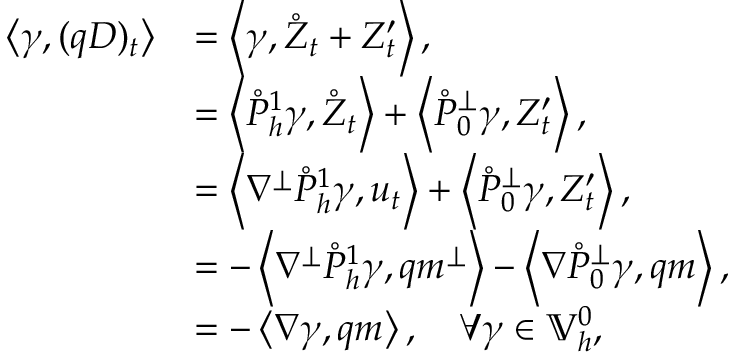<formula> <loc_0><loc_0><loc_500><loc_500>\begin{array} { r l } { \left \langle \gamma , ( q D ) _ { t } \right \rangle } & { = \left \langle \gamma , \mathring { Z } _ { t } + Z _ { t } ^ { \prime } \right \rangle , } \\ & { = \left \langle \mathring { P } _ { h } ^ { 1 } \gamma , \mathring { Z } _ { t } \right \rangle + \left \langle \mathring { P } _ { 0 } ^ { \perp } \gamma , Z _ { t } ^ { \prime } \right \rangle , } \\ & { = \left \langle \nabla ^ { \perp } \mathring { P } _ { h } ^ { 1 } \gamma , u _ { t } \right \rangle + \left \langle \mathring { P } _ { 0 } ^ { \perp } \gamma , Z _ { t } ^ { \prime } \right \rangle , } \\ & { = - \left \langle \nabla ^ { \perp } \mathring { P } _ { h } ^ { 1 } \gamma , q m ^ { \perp } \right \rangle - \left \langle \nabla \mathring { P } _ { 0 } ^ { \perp } \gamma , q m \right \rangle , } \\ & { = - \left \langle \nabla \gamma , q m \right \rangle , \quad \forall \gamma \in \mathbb { V } _ { h } ^ { 0 } , } \end{array}</formula> 